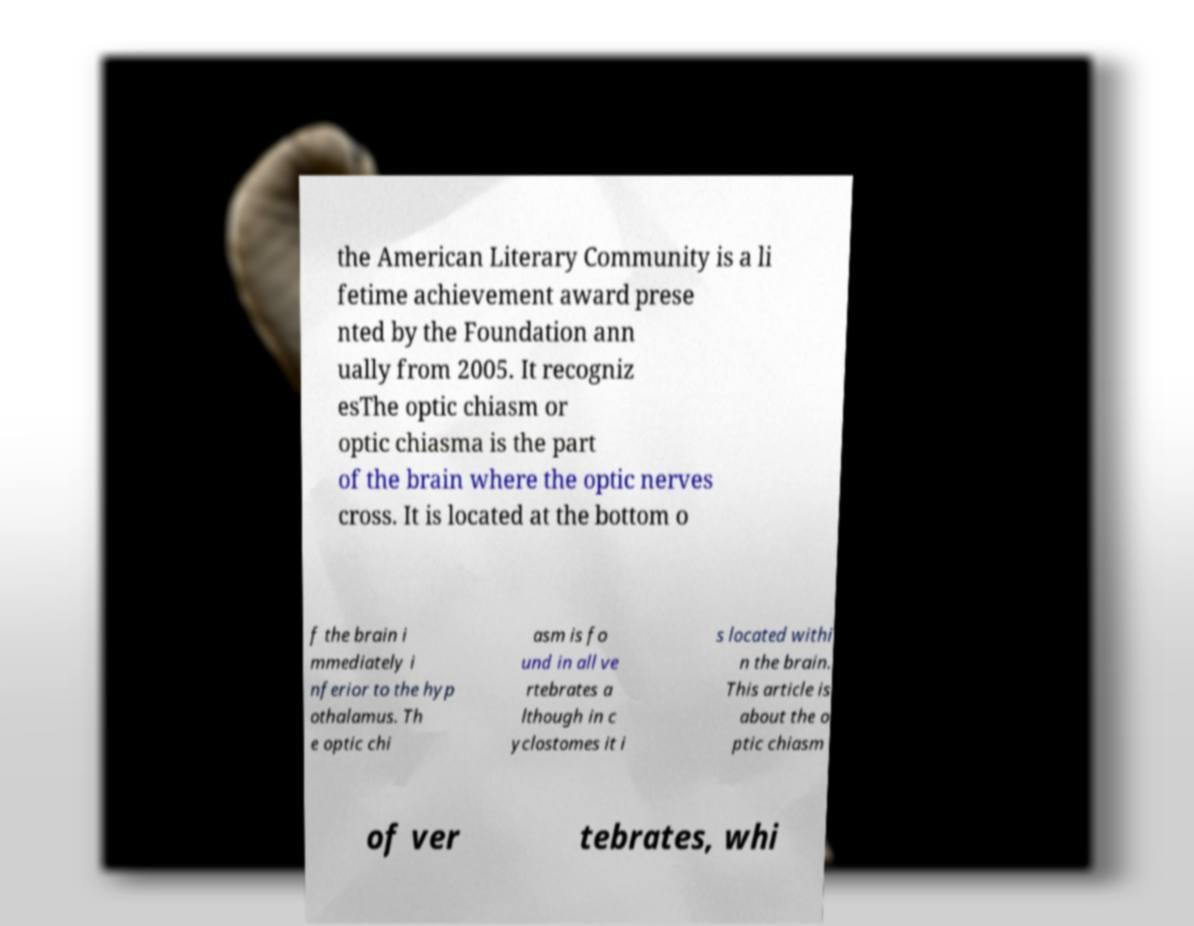Can you accurately transcribe the text from the provided image for me? the American Literary Community is a li fetime achievement award prese nted by the Foundation ann ually from 2005. It recogniz esThe optic chiasm or optic chiasma is the part of the brain where the optic nerves cross. It is located at the bottom o f the brain i mmediately i nferior to the hyp othalamus. Th e optic chi asm is fo und in all ve rtebrates a lthough in c yclostomes it i s located withi n the brain. This article is about the o ptic chiasm of ver tebrates, whi 